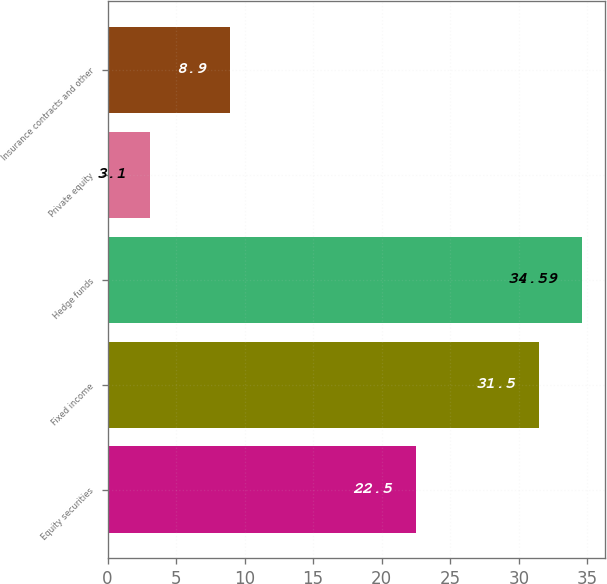<chart> <loc_0><loc_0><loc_500><loc_500><bar_chart><fcel>Equity securities<fcel>Fixed income<fcel>Hedge funds<fcel>Private equity<fcel>Insurance contracts and other<nl><fcel>22.5<fcel>31.5<fcel>34.59<fcel>3.1<fcel>8.9<nl></chart> 